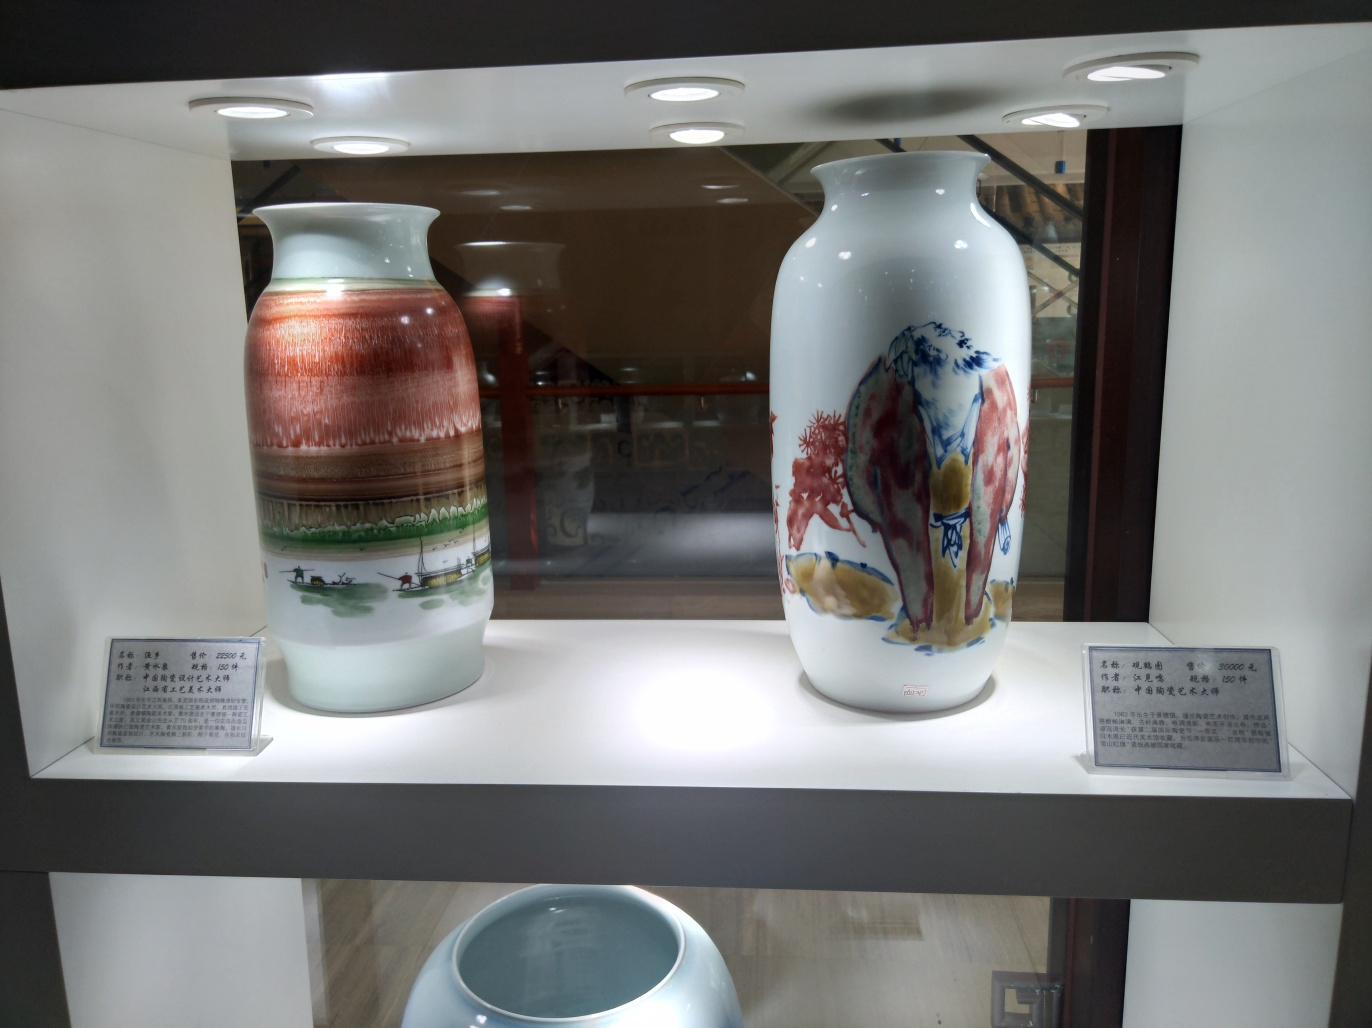What does the lighting tell us about the vases in the image? The lighting emphasizes the importance of the vases, treating them as central, valuable pieces in the exhibit. The bright spotlights create strong highlights, revealing the gloss of the porcelain and showcasing the intricate details of the paintings on the vases. However, the photographic capture of such lighting can sometimes result in glare that might obscure finer details, suggesting that these vases are better appreciated in person rather than through photography. 